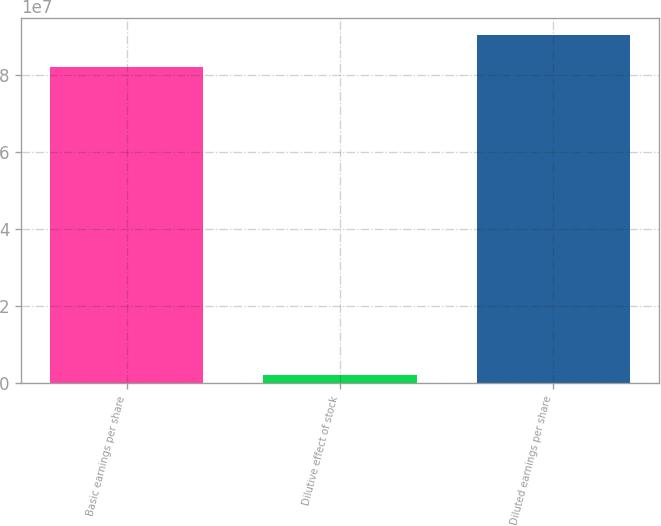Convert chart to OTSL. <chart><loc_0><loc_0><loc_500><loc_500><bar_chart><fcel>Basic earnings per share<fcel>Dilutive effect of stock<fcel>Diluted earnings per share<nl><fcel>8.20579e+07<fcel>2.18595e+06<fcel>9.02636e+07<nl></chart> 